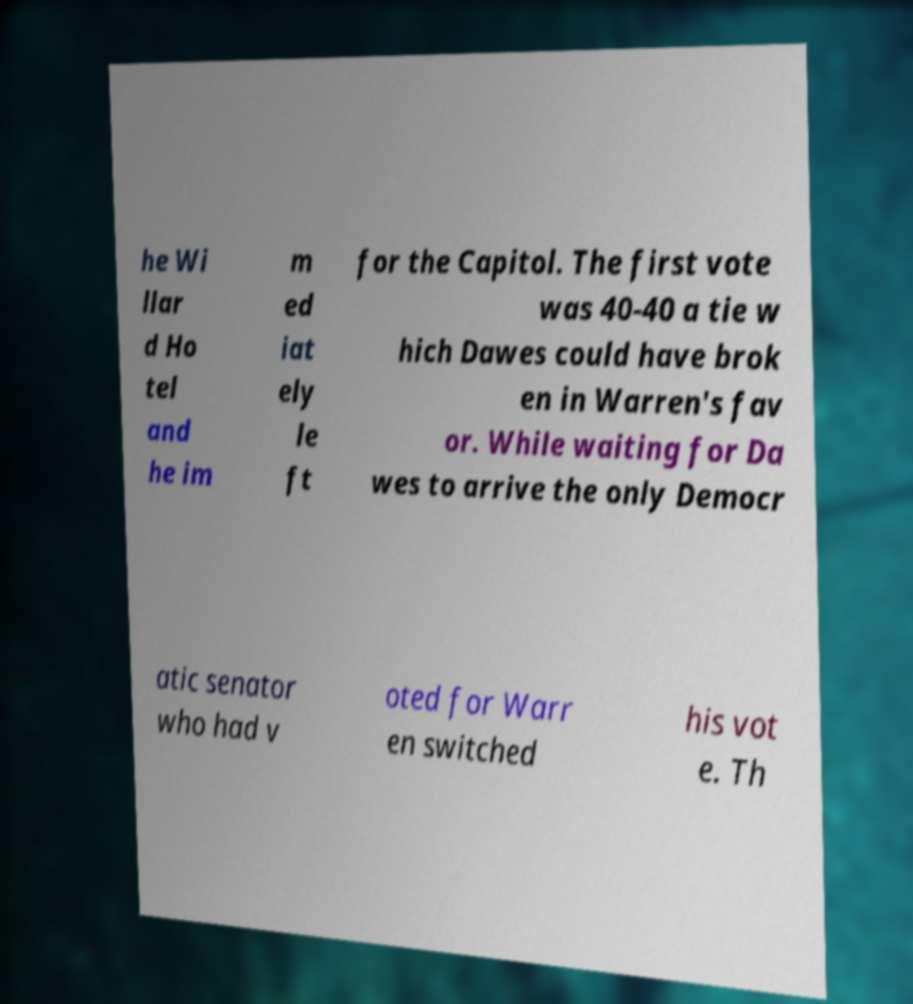Could you extract and type out the text from this image? he Wi llar d Ho tel and he im m ed iat ely le ft for the Capitol. The first vote was 40-40 a tie w hich Dawes could have brok en in Warren's fav or. While waiting for Da wes to arrive the only Democr atic senator who had v oted for Warr en switched his vot e. Th 